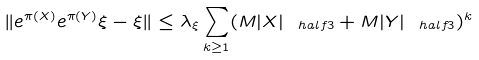<formula> <loc_0><loc_0><loc_500><loc_500>\| e ^ { \pi ( X ) } e ^ { \pi ( Y ) } \xi - \xi \| \leq \lambda _ { \xi } \sum _ { k \geq 1 } ( M | X | _ { \ h a l f { 3 } } + M | Y | _ { \ h a l f { 3 } } ) ^ { k }</formula> 